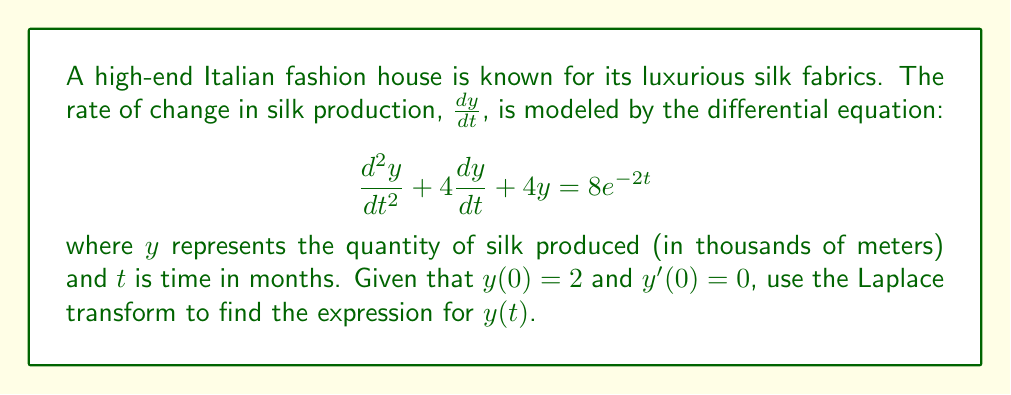Can you solve this math problem? Let's solve this step-by-step using the Laplace transform:

1) First, let's take the Laplace transform of both sides of the equation:

   $\mathcal{L}\{\frac{d^2y}{dt^2} + 4\frac{dy}{dt} + 4y\} = \mathcal{L}\{8e^{-2t}\}$

2) Using the properties of Laplace transforms:

   $s^2Y(s) - sy(0) - y'(0) + 4(sY(s) - y(0)) + 4Y(s) = \frac{8}{s+2}$

3) Substituting the initial conditions $y(0) = 2$ and $y'(0) = 0$:

   $s^2Y(s) - 2s + 4sY(s) - 8 + 4Y(s) = \frac{8}{s+2}$

4) Simplifying:

   $(s^2 + 4s + 4)Y(s) = \frac{8}{s+2} + 2s + 8$

5) Factoring the left side:

   $(s+2)^2Y(s) = \frac{8}{s+2} + 2s + 8$

6) Dividing both sides by $(s+2)^2$:

   $Y(s) = \frac{8}{(s+2)^3} + \frac{2s + 8}{(s+2)^2}$

7) Using partial fraction decomposition:

   $Y(s) = \frac{8}{(s+2)^3} + \frac{2}{s+2} + \frac{2}{(s+2)^2}$

8) Now, we can take the inverse Laplace transform:

   $y(t) = \mathcal{L}^{-1}\{\frac{8}{(s+2)^3} + \frac{2}{s+2} + \frac{2}{(s+2)^2}\}$

9) Using the inverse Laplace transform properties:

   $y(t) = 4t^2e^{-2t} + 2e^{-2t} + 2te^{-2t}$

10) Simplifying:

    $y(t) = (4t^2 + 2t + 2)e^{-2t}$

This is our final expression for $y(t)$.
Answer: $y(t) = (4t^2 + 2t + 2)e^{-2t}$ 